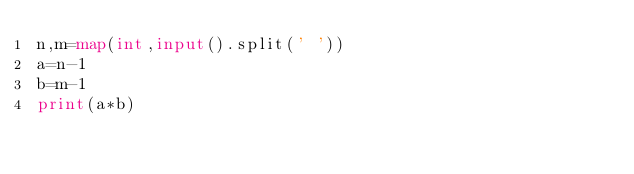<code> <loc_0><loc_0><loc_500><loc_500><_Python_>n,m=map(int,input().split(' '))
a=n-1
b=m-1
print(a*b)
</code> 